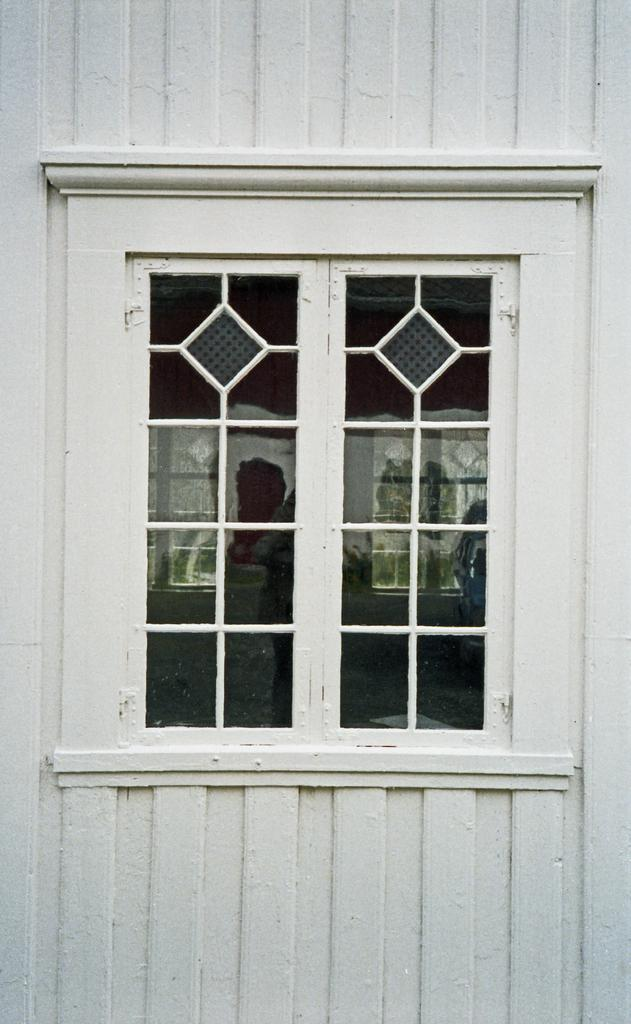What can be seen in the image related to an opening for light and air? There is a window in the image. Where is the window located in relation to the place it is over? The window is positioned over a place. What else can be seen through the window in the image? There are other things visible inside the window. Is there any chalk visible on the window sill in the image? There is no mention of chalk in the provided facts, so it cannot be determined if chalk is present in the image. 